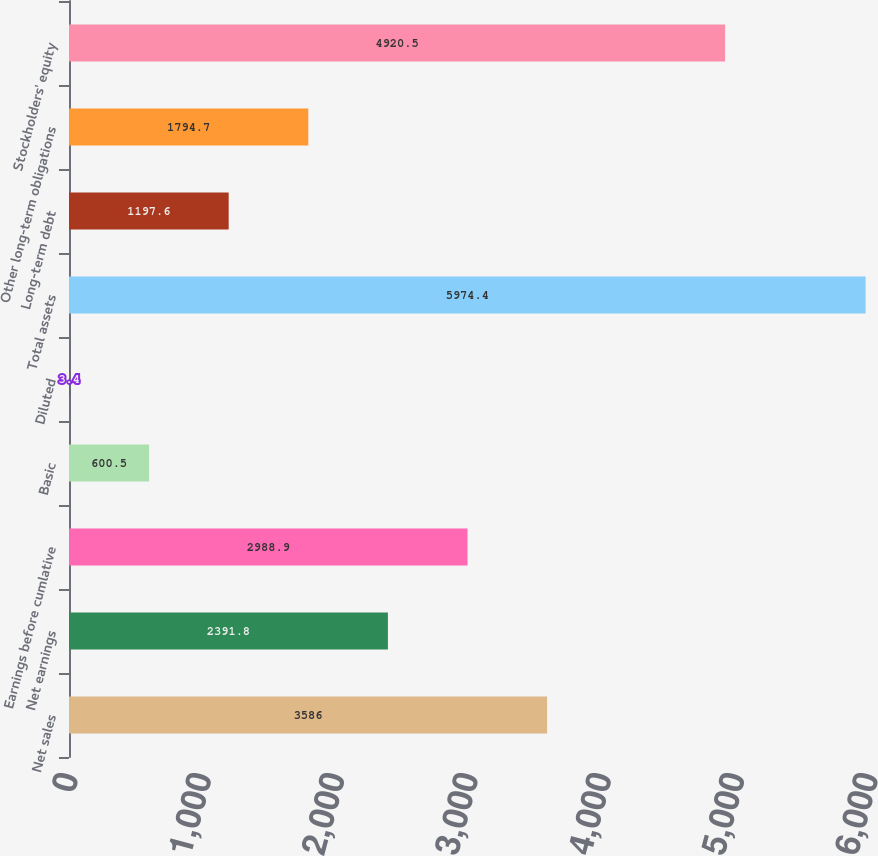<chart> <loc_0><loc_0><loc_500><loc_500><bar_chart><fcel>Net sales<fcel>Net earnings<fcel>Earnings before cumlative<fcel>Basic<fcel>Diluted<fcel>Total assets<fcel>Long-term debt<fcel>Other long-term obligations<fcel>Stockholders' equity<nl><fcel>3586<fcel>2391.8<fcel>2988.9<fcel>600.5<fcel>3.4<fcel>5974.4<fcel>1197.6<fcel>1794.7<fcel>4920.5<nl></chart> 